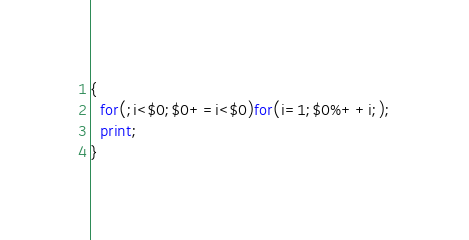Convert code to text. <code><loc_0><loc_0><loc_500><loc_500><_Awk_>{
  for(;i<$0;$0+=i<$0)for(i=1;$0%++i;);
  print;
}</code> 